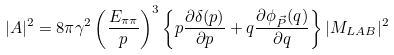Convert formula to latex. <formula><loc_0><loc_0><loc_500><loc_500>| A | ^ { 2 } = 8 \pi \gamma ^ { 2 } \left ( \frac { E _ { \pi \pi } } { p } \right ) ^ { 3 } \left \{ p \frac { \partial \delta ( p ) } { \partial p } + q \frac { \partial \phi _ { \vec { P } } ( q ) } { \partial q } \right \} | M _ { L A B } | ^ { 2 }</formula> 